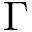Convert formula to latex. <formula><loc_0><loc_0><loc_500><loc_500>\Gamma</formula> 